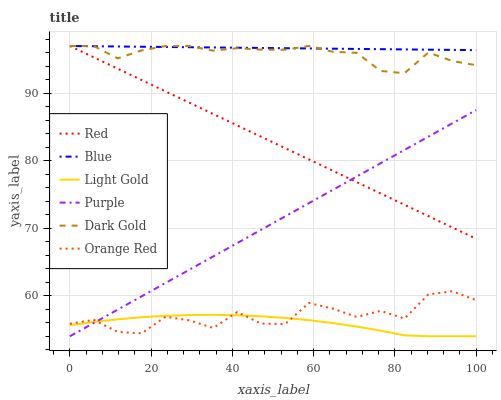Does Light Gold have the minimum area under the curve?
Answer yes or no. Yes. Does Blue have the maximum area under the curve?
Answer yes or no. Yes. Does Dark Gold have the minimum area under the curve?
Answer yes or no. No. Does Dark Gold have the maximum area under the curve?
Answer yes or no. No. Is Blue the smoothest?
Answer yes or no. Yes. Is Orange Red the roughest?
Answer yes or no. Yes. Is Dark Gold the smoothest?
Answer yes or no. No. Is Dark Gold the roughest?
Answer yes or no. No. Does Purple have the lowest value?
Answer yes or no. Yes. Does Dark Gold have the lowest value?
Answer yes or no. No. Does Red have the highest value?
Answer yes or no. Yes. Does Purple have the highest value?
Answer yes or no. No. Is Orange Red less than Dark Gold?
Answer yes or no. Yes. Is Red greater than Orange Red?
Answer yes or no. Yes. Does Red intersect Purple?
Answer yes or no. Yes. Is Red less than Purple?
Answer yes or no. No. Is Red greater than Purple?
Answer yes or no. No. Does Orange Red intersect Dark Gold?
Answer yes or no. No. 